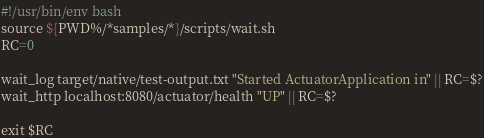Convert code to text. <code><loc_0><loc_0><loc_500><loc_500><_Bash_>#!/usr/bin/env bash
source ${PWD%/*samples/*}/scripts/wait.sh
RC=0

wait_log target/native/test-output.txt "Started ActuatorApplication in" || RC=$?
wait_http localhost:8080/actuator/health "UP" || RC=$?

exit $RC
</code> 